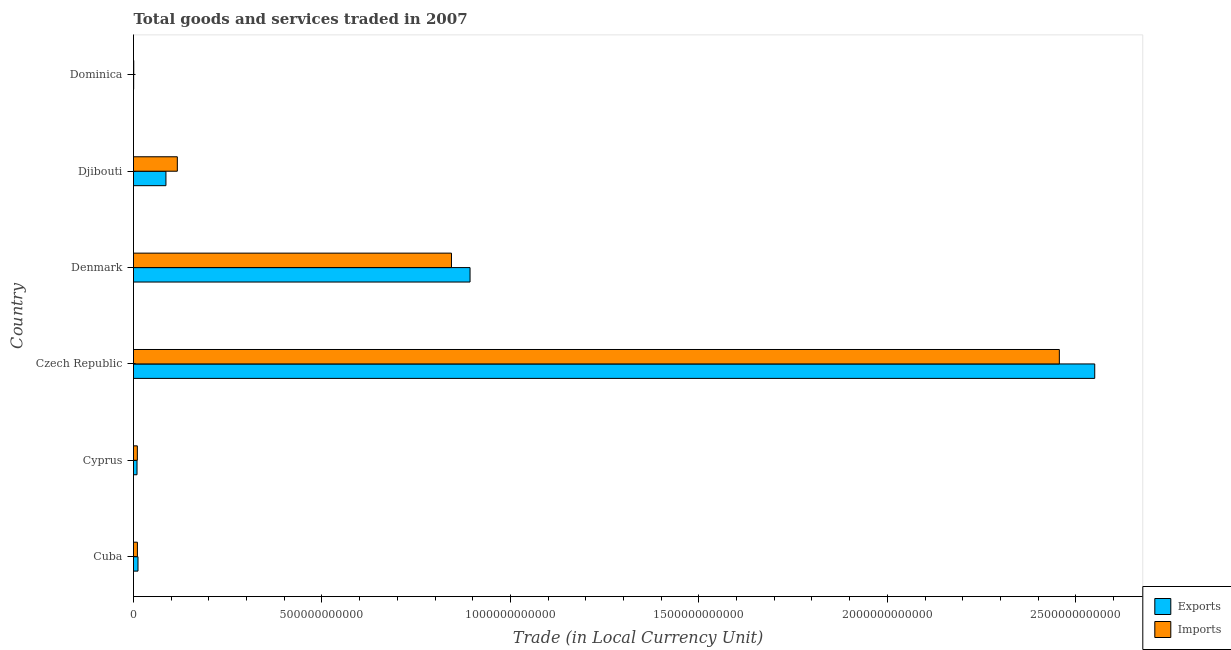How many different coloured bars are there?
Your response must be concise. 2. Are the number of bars on each tick of the Y-axis equal?
Provide a short and direct response. Yes. How many bars are there on the 3rd tick from the top?
Keep it short and to the point. 2. What is the label of the 2nd group of bars from the top?
Offer a very short reply. Djibouti. In how many cases, is the number of bars for a given country not equal to the number of legend labels?
Make the answer very short. 0. What is the imports of goods and services in Cuba?
Give a very brief answer. 1.03e+1. Across all countries, what is the maximum imports of goods and services?
Make the answer very short. 2.46e+12. Across all countries, what is the minimum export of goods and services?
Offer a very short reply. 3.99e+08. In which country was the imports of goods and services maximum?
Make the answer very short. Czech Republic. In which country was the export of goods and services minimum?
Make the answer very short. Dominica. What is the total imports of goods and services in the graph?
Keep it short and to the point. 3.44e+12. What is the difference between the imports of goods and services in Denmark and that in Dominica?
Ensure brevity in your answer.  8.43e+11. What is the difference between the imports of goods and services in Djibouti and the export of goods and services in Denmark?
Give a very brief answer. -7.77e+11. What is the average export of goods and services per country?
Provide a short and direct response. 5.92e+11. What is the difference between the imports of goods and services and export of goods and services in Denmark?
Your answer should be very brief. -4.93e+1. What is the ratio of the export of goods and services in Cuba to that in Czech Republic?
Offer a terse response. 0.01. Is the imports of goods and services in Cyprus less than that in Denmark?
Provide a short and direct response. Yes. What is the difference between the highest and the second highest imports of goods and services?
Keep it short and to the point. 1.61e+12. What is the difference between the highest and the lowest export of goods and services?
Provide a short and direct response. 2.55e+12. In how many countries, is the export of goods and services greater than the average export of goods and services taken over all countries?
Ensure brevity in your answer.  2. What does the 1st bar from the top in Cuba represents?
Make the answer very short. Imports. What does the 2nd bar from the bottom in Czech Republic represents?
Your answer should be very brief. Imports. How many bars are there?
Make the answer very short. 12. What is the difference between two consecutive major ticks on the X-axis?
Give a very brief answer. 5.00e+11. Where does the legend appear in the graph?
Give a very brief answer. Bottom right. How are the legend labels stacked?
Provide a short and direct response. Vertical. What is the title of the graph?
Offer a terse response. Total goods and services traded in 2007. Does "Ages 15-24" appear as one of the legend labels in the graph?
Provide a succinct answer. No. What is the label or title of the X-axis?
Give a very brief answer. Trade (in Local Currency Unit). What is the label or title of the Y-axis?
Provide a short and direct response. Country. What is the Trade (in Local Currency Unit) of Exports in Cuba?
Make the answer very short. 1.19e+1. What is the Trade (in Local Currency Unit) of Imports in Cuba?
Keep it short and to the point. 1.03e+1. What is the Trade (in Local Currency Unit) in Exports in Cyprus?
Your response must be concise. 9.33e+09. What is the Trade (in Local Currency Unit) in Imports in Cyprus?
Offer a terse response. 1.02e+1. What is the Trade (in Local Currency Unit) of Exports in Czech Republic?
Ensure brevity in your answer.  2.55e+12. What is the Trade (in Local Currency Unit) of Imports in Czech Republic?
Provide a succinct answer. 2.46e+12. What is the Trade (in Local Currency Unit) in Exports in Denmark?
Offer a terse response. 8.93e+11. What is the Trade (in Local Currency Unit) of Imports in Denmark?
Give a very brief answer. 8.44e+11. What is the Trade (in Local Currency Unit) in Exports in Djibouti?
Provide a short and direct response. 8.60e+1. What is the Trade (in Local Currency Unit) in Imports in Djibouti?
Provide a succinct answer. 1.16e+11. What is the Trade (in Local Currency Unit) of Exports in Dominica?
Offer a terse response. 3.99e+08. What is the Trade (in Local Currency Unit) of Imports in Dominica?
Make the answer very short. 6.38e+08. Across all countries, what is the maximum Trade (in Local Currency Unit) of Exports?
Give a very brief answer. 2.55e+12. Across all countries, what is the maximum Trade (in Local Currency Unit) in Imports?
Keep it short and to the point. 2.46e+12. Across all countries, what is the minimum Trade (in Local Currency Unit) in Exports?
Keep it short and to the point. 3.99e+08. Across all countries, what is the minimum Trade (in Local Currency Unit) in Imports?
Make the answer very short. 6.38e+08. What is the total Trade (in Local Currency Unit) of Exports in the graph?
Provide a short and direct response. 3.55e+12. What is the total Trade (in Local Currency Unit) of Imports in the graph?
Your response must be concise. 3.44e+12. What is the difference between the Trade (in Local Currency Unit) of Exports in Cuba and that in Cyprus?
Keep it short and to the point. 2.59e+09. What is the difference between the Trade (in Local Currency Unit) in Imports in Cuba and that in Cyprus?
Provide a short and direct response. 1.73e+08. What is the difference between the Trade (in Local Currency Unit) of Exports in Cuba and that in Czech Republic?
Your answer should be compact. -2.54e+12. What is the difference between the Trade (in Local Currency Unit) of Imports in Cuba and that in Czech Republic?
Your answer should be very brief. -2.45e+12. What is the difference between the Trade (in Local Currency Unit) of Exports in Cuba and that in Denmark?
Provide a succinct answer. -8.81e+11. What is the difference between the Trade (in Local Currency Unit) of Imports in Cuba and that in Denmark?
Offer a terse response. -8.33e+11. What is the difference between the Trade (in Local Currency Unit) in Exports in Cuba and that in Djibouti?
Provide a succinct answer. -7.41e+1. What is the difference between the Trade (in Local Currency Unit) in Imports in Cuba and that in Djibouti?
Your answer should be compact. -1.06e+11. What is the difference between the Trade (in Local Currency Unit) in Exports in Cuba and that in Dominica?
Make the answer very short. 1.15e+1. What is the difference between the Trade (in Local Currency Unit) in Imports in Cuba and that in Dominica?
Offer a very short reply. 9.69e+09. What is the difference between the Trade (in Local Currency Unit) of Exports in Cyprus and that in Czech Republic?
Make the answer very short. -2.54e+12. What is the difference between the Trade (in Local Currency Unit) of Imports in Cyprus and that in Czech Republic?
Give a very brief answer. -2.45e+12. What is the difference between the Trade (in Local Currency Unit) of Exports in Cyprus and that in Denmark?
Your response must be concise. -8.84e+11. What is the difference between the Trade (in Local Currency Unit) in Imports in Cyprus and that in Denmark?
Make the answer very short. -8.33e+11. What is the difference between the Trade (in Local Currency Unit) of Exports in Cyprus and that in Djibouti?
Keep it short and to the point. -7.67e+1. What is the difference between the Trade (in Local Currency Unit) of Imports in Cyprus and that in Djibouti?
Ensure brevity in your answer.  -1.06e+11. What is the difference between the Trade (in Local Currency Unit) in Exports in Cyprus and that in Dominica?
Offer a very short reply. 8.93e+09. What is the difference between the Trade (in Local Currency Unit) in Imports in Cyprus and that in Dominica?
Keep it short and to the point. 9.52e+09. What is the difference between the Trade (in Local Currency Unit) in Exports in Czech Republic and that in Denmark?
Provide a succinct answer. 1.66e+12. What is the difference between the Trade (in Local Currency Unit) of Imports in Czech Republic and that in Denmark?
Your response must be concise. 1.61e+12. What is the difference between the Trade (in Local Currency Unit) of Exports in Czech Republic and that in Djibouti?
Provide a succinct answer. 2.46e+12. What is the difference between the Trade (in Local Currency Unit) of Imports in Czech Republic and that in Djibouti?
Offer a terse response. 2.34e+12. What is the difference between the Trade (in Local Currency Unit) in Exports in Czech Republic and that in Dominica?
Make the answer very short. 2.55e+12. What is the difference between the Trade (in Local Currency Unit) in Imports in Czech Republic and that in Dominica?
Make the answer very short. 2.46e+12. What is the difference between the Trade (in Local Currency Unit) in Exports in Denmark and that in Djibouti?
Keep it short and to the point. 8.07e+11. What is the difference between the Trade (in Local Currency Unit) of Imports in Denmark and that in Djibouti?
Your answer should be compact. 7.27e+11. What is the difference between the Trade (in Local Currency Unit) of Exports in Denmark and that in Dominica?
Keep it short and to the point. 8.92e+11. What is the difference between the Trade (in Local Currency Unit) of Imports in Denmark and that in Dominica?
Your response must be concise. 8.43e+11. What is the difference between the Trade (in Local Currency Unit) of Exports in Djibouti and that in Dominica?
Your answer should be very brief. 8.56e+1. What is the difference between the Trade (in Local Currency Unit) of Imports in Djibouti and that in Dominica?
Offer a very short reply. 1.16e+11. What is the difference between the Trade (in Local Currency Unit) in Exports in Cuba and the Trade (in Local Currency Unit) in Imports in Cyprus?
Your response must be concise. 1.76e+09. What is the difference between the Trade (in Local Currency Unit) of Exports in Cuba and the Trade (in Local Currency Unit) of Imports in Czech Republic?
Ensure brevity in your answer.  -2.44e+12. What is the difference between the Trade (in Local Currency Unit) of Exports in Cuba and the Trade (in Local Currency Unit) of Imports in Denmark?
Offer a terse response. -8.32e+11. What is the difference between the Trade (in Local Currency Unit) of Exports in Cuba and the Trade (in Local Currency Unit) of Imports in Djibouti?
Provide a short and direct response. -1.04e+11. What is the difference between the Trade (in Local Currency Unit) in Exports in Cuba and the Trade (in Local Currency Unit) in Imports in Dominica?
Offer a terse response. 1.13e+1. What is the difference between the Trade (in Local Currency Unit) of Exports in Cyprus and the Trade (in Local Currency Unit) of Imports in Czech Republic?
Make the answer very short. -2.45e+12. What is the difference between the Trade (in Local Currency Unit) of Exports in Cyprus and the Trade (in Local Currency Unit) of Imports in Denmark?
Ensure brevity in your answer.  -8.34e+11. What is the difference between the Trade (in Local Currency Unit) of Exports in Cyprus and the Trade (in Local Currency Unit) of Imports in Djibouti?
Keep it short and to the point. -1.07e+11. What is the difference between the Trade (in Local Currency Unit) in Exports in Cyprus and the Trade (in Local Currency Unit) in Imports in Dominica?
Keep it short and to the point. 8.69e+09. What is the difference between the Trade (in Local Currency Unit) of Exports in Czech Republic and the Trade (in Local Currency Unit) of Imports in Denmark?
Your answer should be very brief. 1.71e+12. What is the difference between the Trade (in Local Currency Unit) of Exports in Czech Republic and the Trade (in Local Currency Unit) of Imports in Djibouti?
Provide a succinct answer. 2.43e+12. What is the difference between the Trade (in Local Currency Unit) in Exports in Czech Republic and the Trade (in Local Currency Unit) in Imports in Dominica?
Keep it short and to the point. 2.55e+12. What is the difference between the Trade (in Local Currency Unit) of Exports in Denmark and the Trade (in Local Currency Unit) of Imports in Djibouti?
Offer a very short reply. 7.77e+11. What is the difference between the Trade (in Local Currency Unit) of Exports in Denmark and the Trade (in Local Currency Unit) of Imports in Dominica?
Ensure brevity in your answer.  8.92e+11. What is the difference between the Trade (in Local Currency Unit) of Exports in Djibouti and the Trade (in Local Currency Unit) of Imports in Dominica?
Your answer should be compact. 8.54e+1. What is the average Trade (in Local Currency Unit) in Exports per country?
Your answer should be very brief. 5.92e+11. What is the average Trade (in Local Currency Unit) of Imports per country?
Your response must be concise. 5.73e+11. What is the difference between the Trade (in Local Currency Unit) in Exports and Trade (in Local Currency Unit) in Imports in Cuba?
Keep it short and to the point. 1.59e+09. What is the difference between the Trade (in Local Currency Unit) in Exports and Trade (in Local Currency Unit) in Imports in Cyprus?
Keep it short and to the point. -8.33e+08. What is the difference between the Trade (in Local Currency Unit) of Exports and Trade (in Local Currency Unit) of Imports in Czech Republic?
Your response must be concise. 9.39e+1. What is the difference between the Trade (in Local Currency Unit) of Exports and Trade (in Local Currency Unit) of Imports in Denmark?
Ensure brevity in your answer.  4.93e+1. What is the difference between the Trade (in Local Currency Unit) of Exports and Trade (in Local Currency Unit) of Imports in Djibouti?
Provide a succinct answer. -3.02e+1. What is the difference between the Trade (in Local Currency Unit) in Exports and Trade (in Local Currency Unit) in Imports in Dominica?
Keep it short and to the point. -2.39e+08. What is the ratio of the Trade (in Local Currency Unit) of Exports in Cuba to that in Cyprus?
Make the answer very short. 1.28. What is the ratio of the Trade (in Local Currency Unit) of Imports in Cuba to that in Cyprus?
Keep it short and to the point. 1.02. What is the ratio of the Trade (in Local Currency Unit) of Exports in Cuba to that in Czech Republic?
Ensure brevity in your answer.  0. What is the ratio of the Trade (in Local Currency Unit) of Imports in Cuba to that in Czech Republic?
Your answer should be very brief. 0. What is the ratio of the Trade (in Local Currency Unit) in Exports in Cuba to that in Denmark?
Make the answer very short. 0.01. What is the ratio of the Trade (in Local Currency Unit) in Imports in Cuba to that in Denmark?
Your answer should be very brief. 0.01. What is the ratio of the Trade (in Local Currency Unit) in Exports in Cuba to that in Djibouti?
Provide a short and direct response. 0.14. What is the ratio of the Trade (in Local Currency Unit) of Imports in Cuba to that in Djibouti?
Offer a very short reply. 0.09. What is the ratio of the Trade (in Local Currency Unit) of Exports in Cuba to that in Dominica?
Give a very brief answer. 29.87. What is the ratio of the Trade (in Local Currency Unit) in Imports in Cuba to that in Dominica?
Provide a short and direct response. 16.2. What is the ratio of the Trade (in Local Currency Unit) of Exports in Cyprus to that in Czech Republic?
Offer a very short reply. 0. What is the ratio of the Trade (in Local Currency Unit) of Imports in Cyprus to that in Czech Republic?
Give a very brief answer. 0. What is the ratio of the Trade (in Local Currency Unit) in Exports in Cyprus to that in Denmark?
Your response must be concise. 0.01. What is the ratio of the Trade (in Local Currency Unit) of Imports in Cyprus to that in Denmark?
Your answer should be compact. 0.01. What is the ratio of the Trade (in Local Currency Unit) of Exports in Cyprus to that in Djibouti?
Your response must be concise. 0.11. What is the ratio of the Trade (in Local Currency Unit) in Imports in Cyprus to that in Djibouti?
Give a very brief answer. 0.09. What is the ratio of the Trade (in Local Currency Unit) of Exports in Cyprus to that in Dominica?
Keep it short and to the point. 23.37. What is the ratio of the Trade (in Local Currency Unit) in Imports in Cyprus to that in Dominica?
Ensure brevity in your answer.  15.92. What is the ratio of the Trade (in Local Currency Unit) of Exports in Czech Republic to that in Denmark?
Your response must be concise. 2.86. What is the ratio of the Trade (in Local Currency Unit) in Imports in Czech Republic to that in Denmark?
Provide a short and direct response. 2.91. What is the ratio of the Trade (in Local Currency Unit) of Exports in Czech Republic to that in Djibouti?
Your answer should be compact. 29.64. What is the ratio of the Trade (in Local Currency Unit) in Imports in Czech Republic to that in Djibouti?
Give a very brief answer. 21.13. What is the ratio of the Trade (in Local Currency Unit) in Exports in Czech Republic to that in Dominica?
Make the answer very short. 6391.43. What is the ratio of the Trade (in Local Currency Unit) in Imports in Czech Republic to that in Dominica?
Your answer should be very brief. 3849.98. What is the ratio of the Trade (in Local Currency Unit) in Exports in Denmark to that in Djibouti?
Your answer should be very brief. 10.38. What is the ratio of the Trade (in Local Currency Unit) in Imports in Denmark to that in Djibouti?
Your answer should be very brief. 7.26. What is the ratio of the Trade (in Local Currency Unit) in Exports in Denmark to that in Dominica?
Offer a very short reply. 2237.78. What is the ratio of the Trade (in Local Currency Unit) of Imports in Denmark to that in Dominica?
Keep it short and to the point. 1322.23. What is the ratio of the Trade (in Local Currency Unit) in Exports in Djibouti to that in Dominica?
Your answer should be very brief. 215.61. What is the ratio of the Trade (in Local Currency Unit) in Imports in Djibouti to that in Dominica?
Offer a very short reply. 182.22. What is the difference between the highest and the second highest Trade (in Local Currency Unit) of Exports?
Keep it short and to the point. 1.66e+12. What is the difference between the highest and the second highest Trade (in Local Currency Unit) in Imports?
Your answer should be very brief. 1.61e+12. What is the difference between the highest and the lowest Trade (in Local Currency Unit) of Exports?
Make the answer very short. 2.55e+12. What is the difference between the highest and the lowest Trade (in Local Currency Unit) of Imports?
Your answer should be very brief. 2.46e+12. 